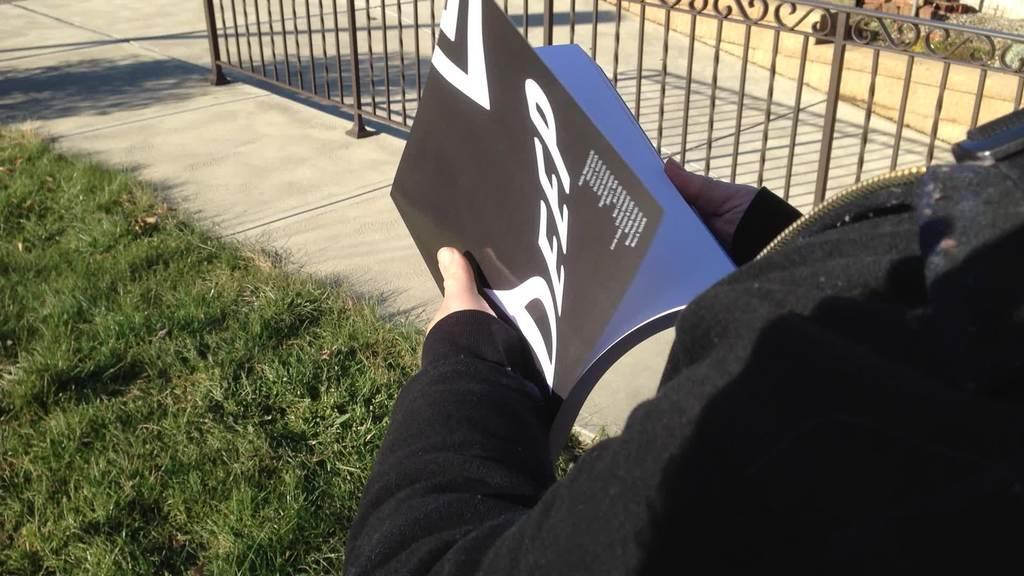Who or what is present in the image? There is a person in the image. What is the person holding? The person is holding a book. What type of vegetation can be seen on the ground in the image? Grass is visible on the left side of the image. What is located on the right side of the image? There is fencing on the right side of the image. What type of cushion is the person sitting on in the image? There is no cushion present in the image, nor is the person sitting down. 